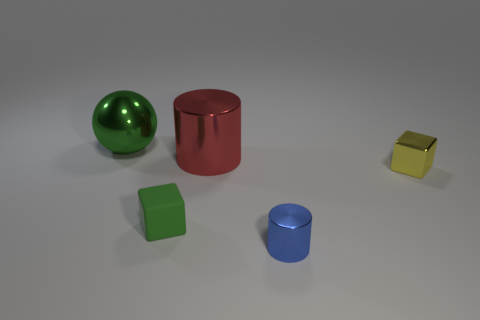Is the number of rubber objects that are in front of the big metallic cylinder less than the number of green objects that are in front of the green cube?
Provide a succinct answer. No. Are there any other things that are the same shape as the small yellow metallic object?
Provide a short and direct response. Yes. There is a big thing that is the same color as the matte cube; what material is it?
Offer a terse response. Metal. There is a tiny thing to the left of the big shiny thing that is right of the small green cube; what number of cylinders are in front of it?
Your response must be concise. 1. There is a large metal cylinder; what number of yellow metal blocks are on the right side of it?
Offer a terse response. 1. What number of other objects are the same material as the tiny blue thing?
Make the answer very short. 3. What is the color of the sphere that is the same material as the tiny blue object?
Make the answer very short. Green. The green object that is behind the tiny block that is right of the large metal cylinder to the left of the small yellow block is made of what material?
Offer a terse response. Metal. There is a blue shiny cylinder that is in front of the sphere; is it the same size as the small matte block?
Provide a succinct answer. Yes. How many big objects are either cubes or cyan objects?
Ensure brevity in your answer.  0. 